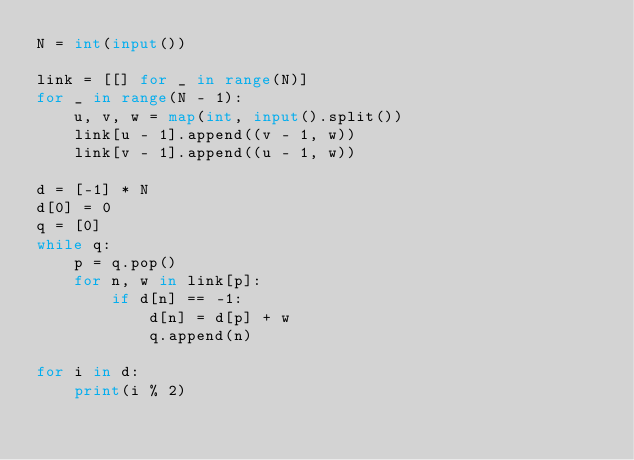Convert code to text. <code><loc_0><loc_0><loc_500><loc_500><_Python_>N = int(input())

link = [[] for _ in range(N)]
for _ in range(N - 1):
    u, v, w = map(int, input().split())
    link[u - 1].append((v - 1, w))
    link[v - 1].append((u - 1, w))

d = [-1] * N
d[0] = 0
q = [0]
while q:
    p = q.pop()
    for n, w in link[p]:
        if d[n] == -1:
            d[n] = d[p] + w
            q.append(n)

for i in d:
    print(i % 2)
</code> 